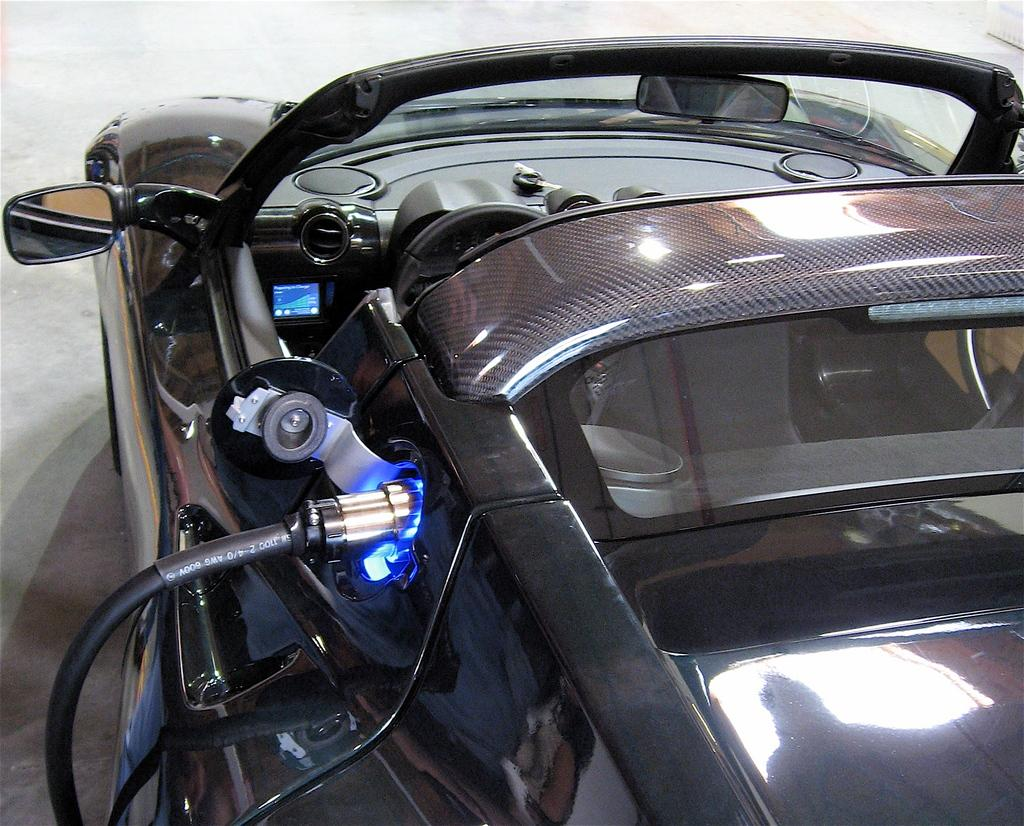What is the main subject of the image? The main subject of the image is a car. How much of the car is visible in the image? The car is truncated or partially visible in the image. What type of rice is being served in the image? There is no rice present in the image; it features a car that is partially visible. How many chairs are visible in the image? There are no chairs visible in the image; it features a car that is partially visible. 